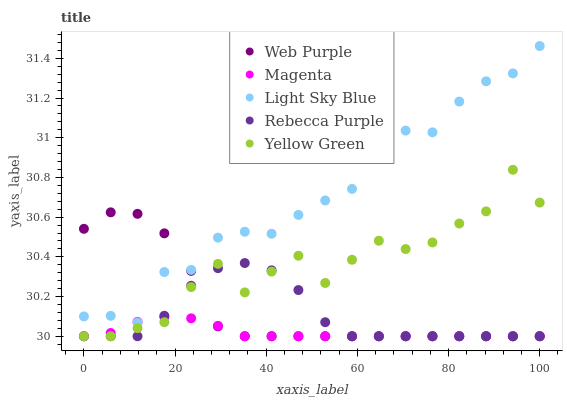Does Magenta have the minimum area under the curve?
Answer yes or no. Yes. Does Light Sky Blue have the maximum area under the curve?
Answer yes or no. Yes. Does Web Purple have the minimum area under the curve?
Answer yes or no. No. Does Web Purple have the maximum area under the curve?
Answer yes or no. No. Is Magenta the smoothest?
Answer yes or no. Yes. Is Yellow Green the roughest?
Answer yes or no. Yes. Is Web Purple the smoothest?
Answer yes or no. No. Is Web Purple the roughest?
Answer yes or no. No. Does Yellow Green have the lowest value?
Answer yes or no. Yes. Does Light Sky Blue have the lowest value?
Answer yes or no. No. Does Light Sky Blue have the highest value?
Answer yes or no. Yes. Does Web Purple have the highest value?
Answer yes or no. No. Is Rebecca Purple less than Light Sky Blue?
Answer yes or no. Yes. Is Light Sky Blue greater than Yellow Green?
Answer yes or no. Yes. Does Rebecca Purple intersect Web Purple?
Answer yes or no. Yes. Is Rebecca Purple less than Web Purple?
Answer yes or no. No. Is Rebecca Purple greater than Web Purple?
Answer yes or no. No. Does Rebecca Purple intersect Light Sky Blue?
Answer yes or no. No. 